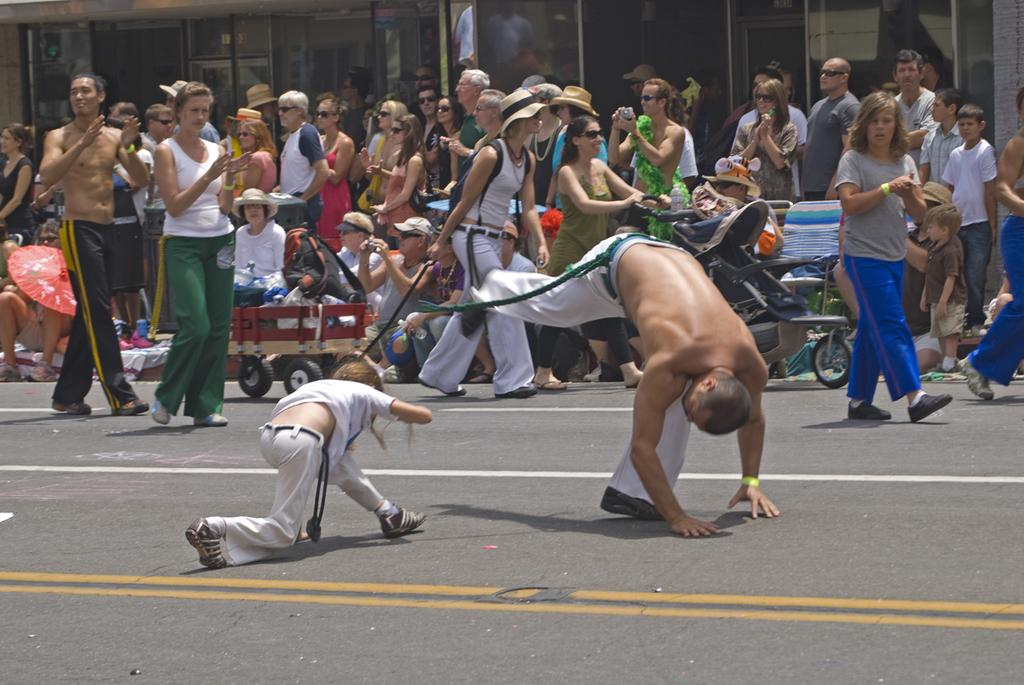How many people are in the image? There is a group of people in the image. What are the people in the image doing? Some people are standing, while others are walking. Where are the people located? The people are on a road. What additional items can be seen in the image? There is a stroller, an umbrella, and a cart in the image. What form of approval is required for the cart in the image? There is no indication in the image that any form of approval is required for the cart. 